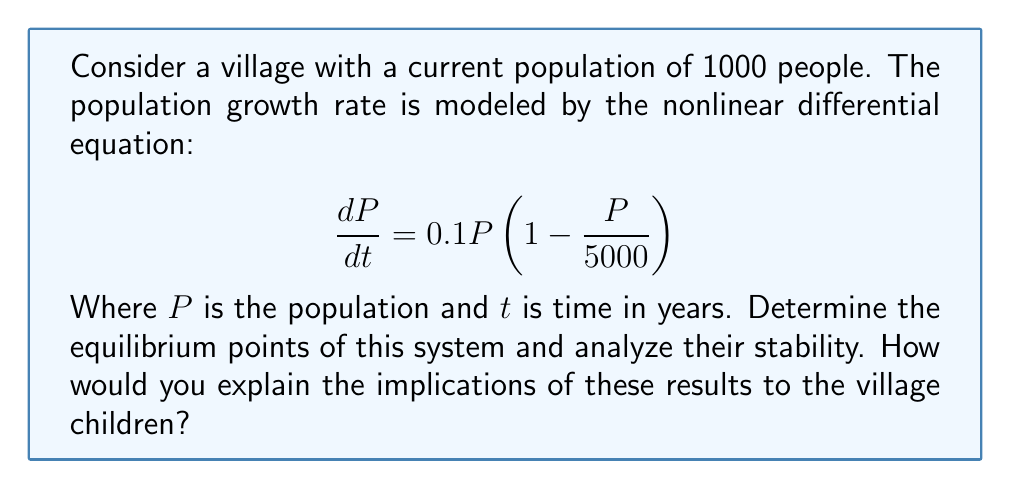Can you answer this question? 1. Find the equilibrium points:
   Set $\frac{dP}{dt} = 0$ and solve for $P$:
   $$ 0 = 0.1P\left(1 - \frac{P}{5000}\right) $$
   
   This equation is satisfied when $P = 0$ or $P = 5000$.

2. Analyze stability:
   Calculate the derivative of $\frac{dP}{dt}$ with respect to $P$:
   $$ \frac{d}{dP}\left(\frac{dP}{dt}\right) = 0.1 - \frac{0.2P}{5000} = 0.1\left(1 - \frac{P}{2500}\right) $$

   Evaluate at each equilibrium point:
   
   At $P = 0$: $0.1(1 - 0) = 0.1 > 0$ (unstable)
   At $P = 5000$: $0.1(1 - 2) = -0.1 < 0$ (stable)

3. Interpretation for village children:
   - The village population will naturally grow towards 5000 people.
   - If there are fewer than 5000 people, the population will increase.
   - If there are more than 5000 people, the population will decrease.
   - 5000 is the "just right" number for the village, like Goldilocks' porridge.
   - The current population of 1000 will grow over time, but not forever.
Answer: Two equilibrium points: $P = 0$ (unstable) and $P = 5000$ (stable). The village population will tend towards 5000 people over time. 